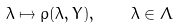<formula> <loc_0><loc_0><loc_500><loc_500>\lambda \mapsto \rho ( \lambda , Y ) , \quad \lambda \in \Lambda</formula> 